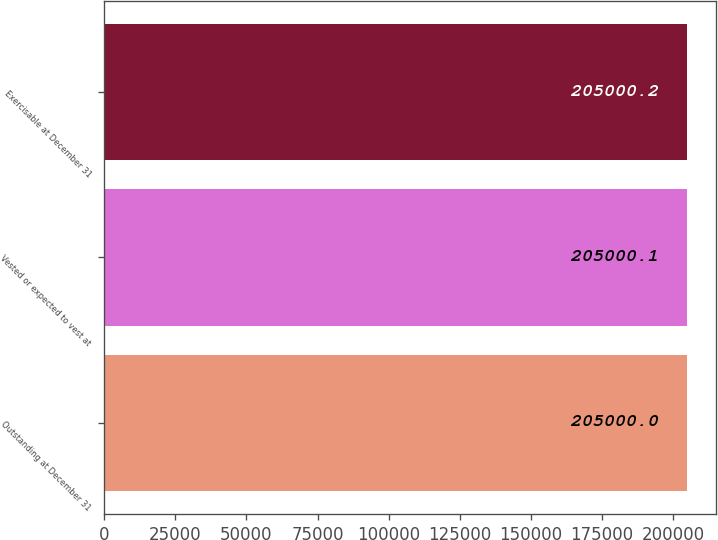<chart> <loc_0><loc_0><loc_500><loc_500><bar_chart><fcel>Outstanding at December 31<fcel>Vested or expected to vest at<fcel>Exercisable at December 31<nl><fcel>205000<fcel>205000<fcel>205000<nl></chart> 